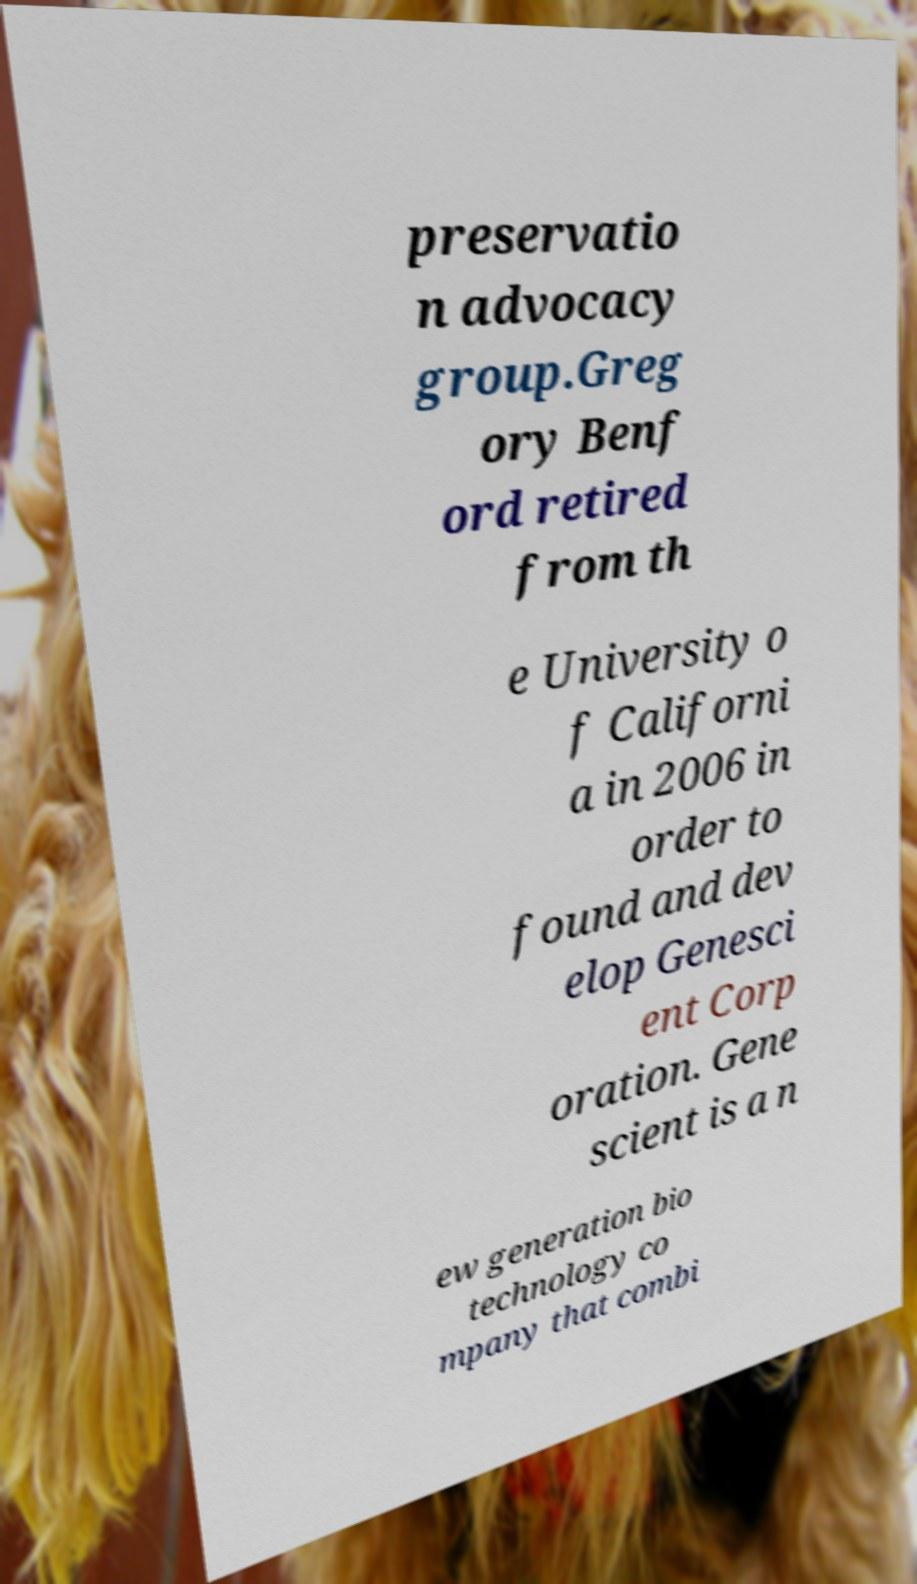What messages or text are displayed in this image? I need them in a readable, typed format. preservatio n advocacy group.Greg ory Benf ord retired from th e University o f Californi a in 2006 in order to found and dev elop Genesci ent Corp oration. Gene scient is a n ew generation bio technology co mpany that combi 